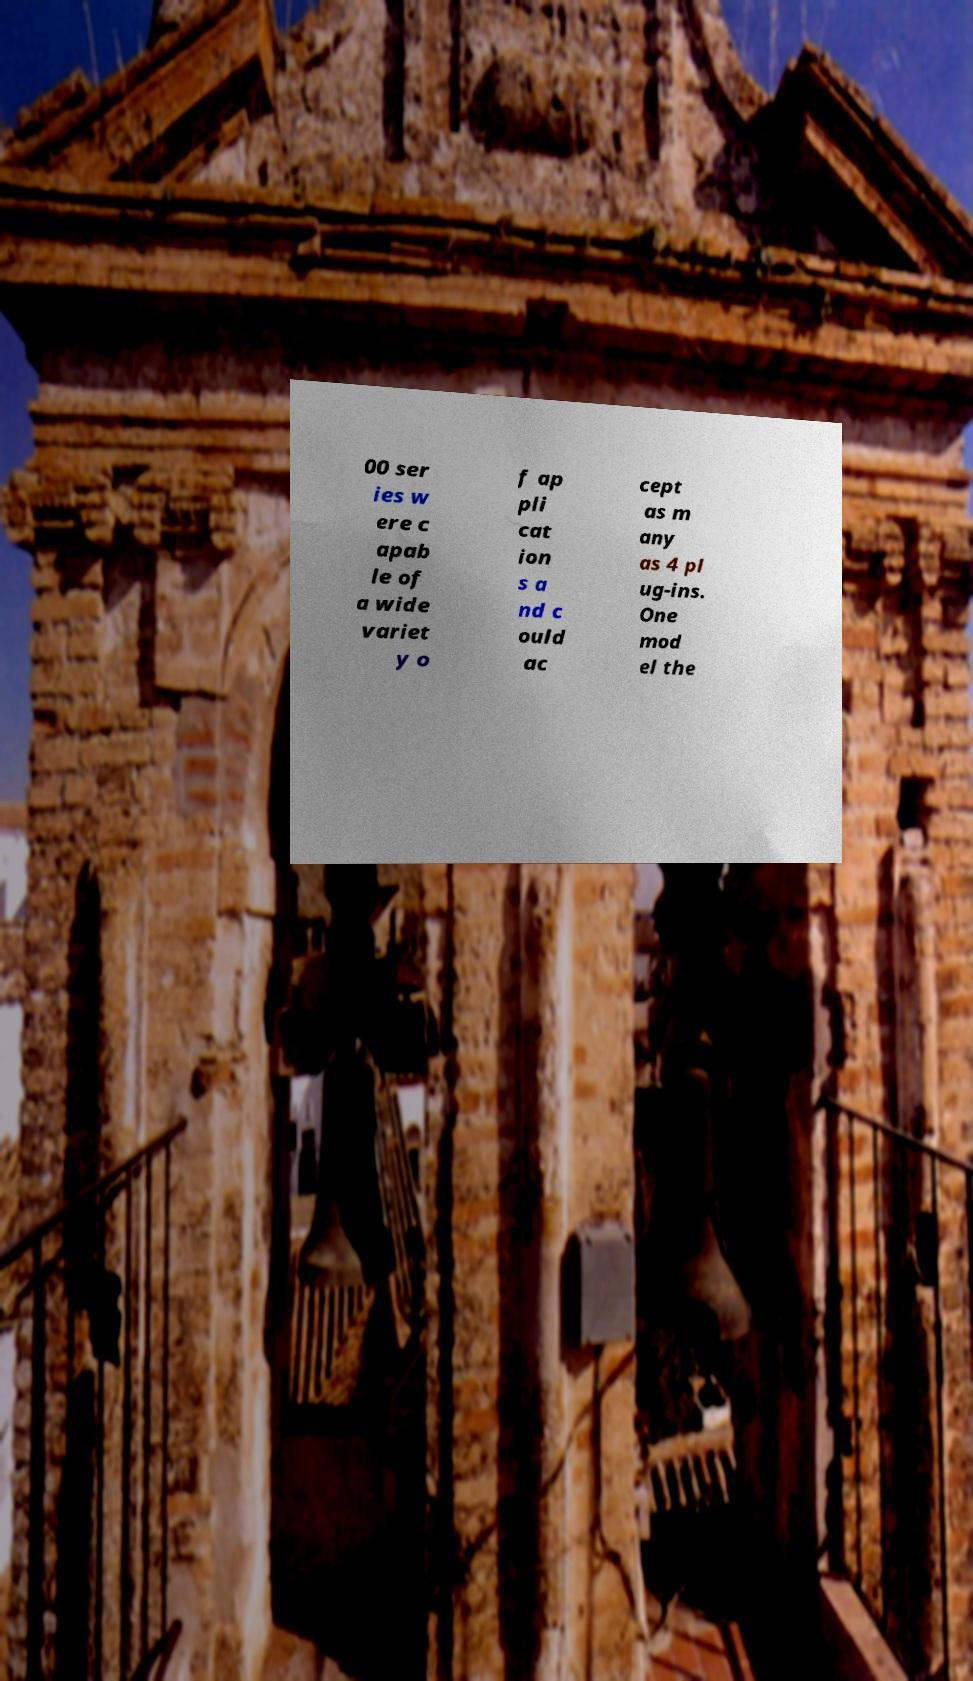What messages or text are displayed in this image? I need them in a readable, typed format. 00 ser ies w ere c apab le of a wide variet y o f ap pli cat ion s a nd c ould ac cept as m any as 4 pl ug-ins. One mod el the 